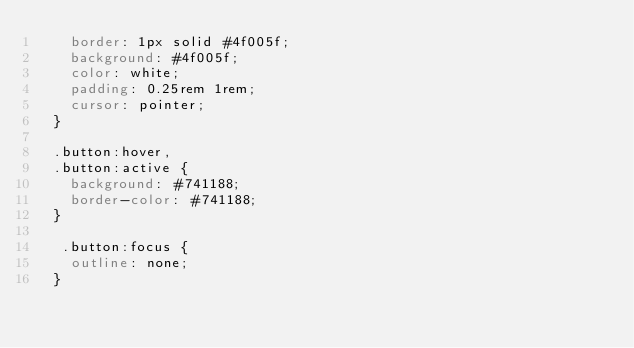Convert code to text. <code><loc_0><loc_0><loc_500><loc_500><_CSS_>    border: 1px solid #4f005f;
    background: #4f005f;
    color: white;
    padding: 0.25rem 1rem;
    cursor: pointer;
  }
  
  .button:hover,
  .button:active {
    background: #741188;
    border-color: #741188;
  }
  
   .button:focus {
    outline: none;
  } </code> 